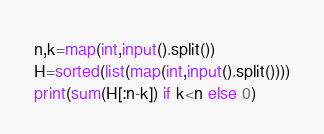Convert code to text. <code><loc_0><loc_0><loc_500><loc_500><_Python_>n,k=map(int,input().split())
H=sorted(list(map(int,input().split())))
print(sum(H[:n-k]) if k<n else 0) </code> 